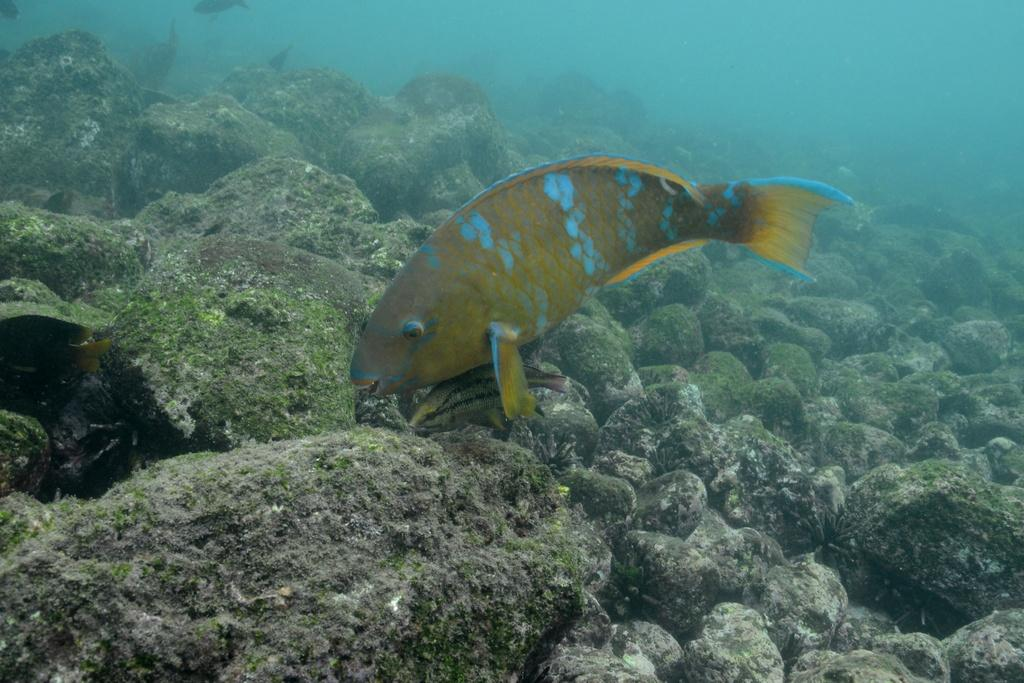What type of animal can be seen in the water in the image? There is a fish in the water in the image. What other objects or features can be seen in the image? There are stones visible in the image. Can you describe the appearance of the stones? Algae is present on the stones in the image. What type of pear is being sold at the store in the image? There is no store or pear present in the image; it features a fish in the water and stones with algae. 